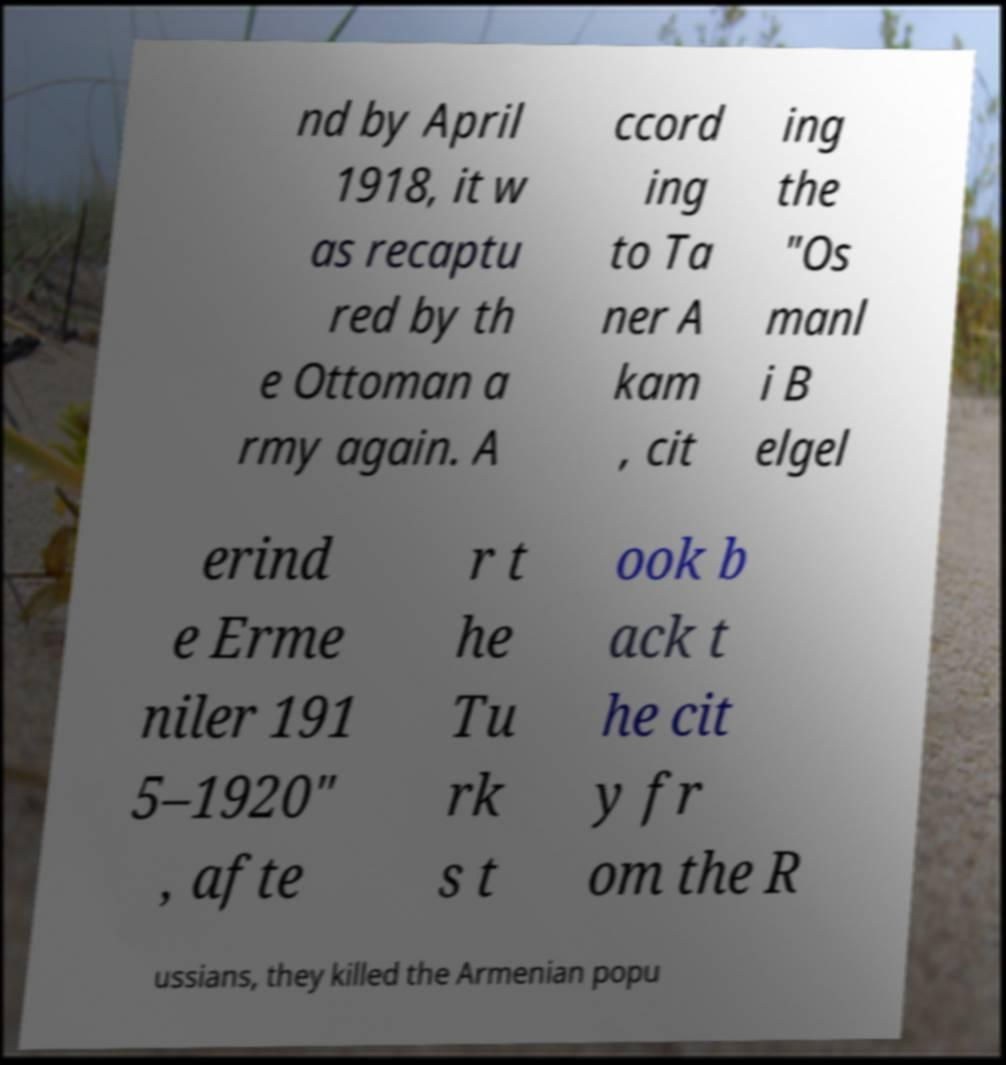Could you extract and type out the text from this image? nd by April 1918, it w as recaptu red by th e Ottoman a rmy again. A ccord ing to Ta ner A kam , cit ing the "Os manl i B elgel erind e Erme niler 191 5–1920" , afte r t he Tu rk s t ook b ack t he cit y fr om the R ussians, they killed the Armenian popu 